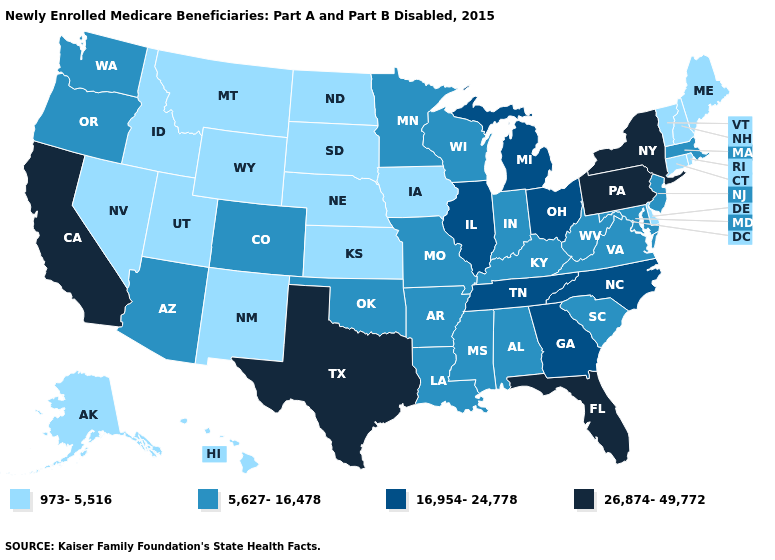Among the states that border Louisiana , does Texas have the lowest value?
Give a very brief answer. No. Name the states that have a value in the range 16,954-24,778?
Quick response, please. Georgia, Illinois, Michigan, North Carolina, Ohio, Tennessee. Which states have the highest value in the USA?
Keep it brief. California, Florida, New York, Pennsylvania, Texas. Name the states that have a value in the range 5,627-16,478?
Short answer required. Alabama, Arizona, Arkansas, Colorado, Indiana, Kentucky, Louisiana, Maryland, Massachusetts, Minnesota, Mississippi, Missouri, New Jersey, Oklahoma, Oregon, South Carolina, Virginia, Washington, West Virginia, Wisconsin. Which states have the highest value in the USA?
Quick response, please. California, Florida, New York, Pennsylvania, Texas. Does New York have the lowest value in the USA?
Be succinct. No. Does New Mexico have a lower value than Missouri?
Answer briefly. Yes. What is the lowest value in the USA?
Keep it brief. 973-5,516. What is the highest value in the West ?
Concise answer only. 26,874-49,772. Name the states that have a value in the range 973-5,516?
Answer briefly. Alaska, Connecticut, Delaware, Hawaii, Idaho, Iowa, Kansas, Maine, Montana, Nebraska, Nevada, New Hampshire, New Mexico, North Dakota, Rhode Island, South Dakota, Utah, Vermont, Wyoming. What is the value of Connecticut?
Quick response, please. 973-5,516. What is the value of Arkansas?
Give a very brief answer. 5,627-16,478. Name the states that have a value in the range 16,954-24,778?
Quick response, please. Georgia, Illinois, Michigan, North Carolina, Ohio, Tennessee. How many symbols are there in the legend?
Quick response, please. 4. Does the first symbol in the legend represent the smallest category?
Quick response, please. Yes. 